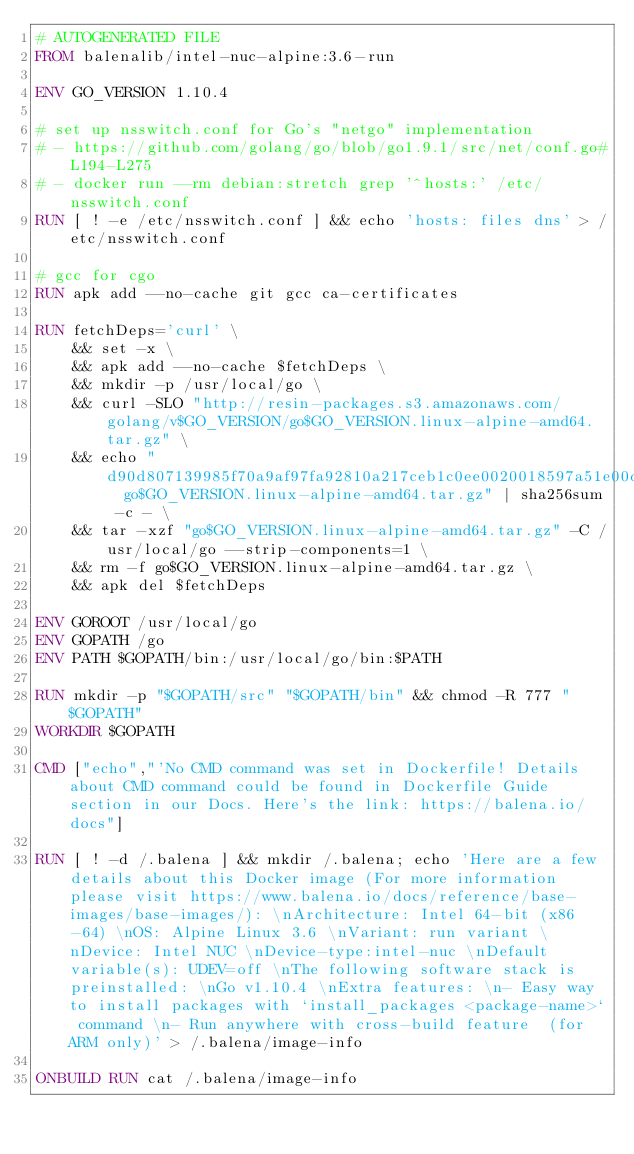Convert code to text. <code><loc_0><loc_0><loc_500><loc_500><_Dockerfile_># AUTOGENERATED FILE
FROM balenalib/intel-nuc-alpine:3.6-run

ENV GO_VERSION 1.10.4

# set up nsswitch.conf for Go's "netgo" implementation
# - https://github.com/golang/go/blob/go1.9.1/src/net/conf.go#L194-L275
# - docker run --rm debian:stretch grep '^hosts:' /etc/nsswitch.conf
RUN [ ! -e /etc/nsswitch.conf ] && echo 'hosts: files dns' > /etc/nsswitch.conf

# gcc for cgo
RUN apk add --no-cache git gcc ca-certificates

RUN fetchDeps='curl' \
	&& set -x \
	&& apk add --no-cache $fetchDeps \
	&& mkdir -p /usr/local/go \
	&& curl -SLO "http://resin-packages.s3.amazonaws.com/golang/v$GO_VERSION/go$GO_VERSION.linux-alpine-amd64.tar.gz" \
	&& echo "d90d807139985f70a9af97fa92810a217ceb1c0ee0020018597a51e00d2dce79  go$GO_VERSION.linux-alpine-amd64.tar.gz" | sha256sum -c - \
	&& tar -xzf "go$GO_VERSION.linux-alpine-amd64.tar.gz" -C /usr/local/go --strip-components=1 \
	&& rm -f go$GO_VERSION.linux-alpine-amd64.tar.gz \
	&& apk del $fetchDeps

ENV GOROOT /usr/local/go
ENV GOPATH /go
ENV PATH $GOPATH/bin:/usr/local/go/bin:$PATH

RUN mkdir -p "$GOPATH/src" "$GOPATH/bin" && chmod -R 777 "$GOPATH"
WORKDIR $GOPATH

CMD ["echo","'No CMD command was set in Dockerfile! Details about CMD command could be found in Dockerfile Guide section in our Docs. Here's the link: https://balena.io/docs"]

RUN [ ! -d /.balena ] && mkdir /.balena; echo 'Here are a few details about this Docker image (For more information please visit https://www.balena.io/docs/reference/base-images/base-images/): \nArchitecture: Intel 64-bit (x86-64) \nOS: Alpine Linux 3.6 \nVariant: run variant \nDevice: Intel NUC \nDevice-type:intel-nuc \nDefault variable(s): UDEV=off \nThe following software stack is preinstalled: \nGo v1.10.4 \nExtra features: \n- Easy way to install packages with `install_packages <package-name>` command \n- Run anywhere with cross-build feature  (for ARM only)' > /.balena/image-info

ONBUILD RUN cat /.balena/image-info</code> 